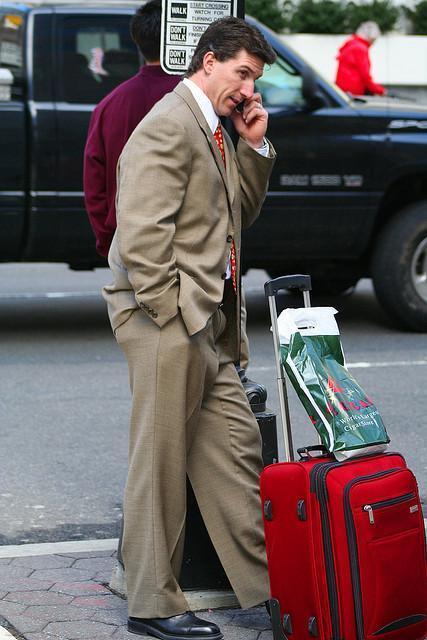How many people are there?
Give a very brief answer. 3. How many suitcases can you see?
Give a very brief answer. 2. 